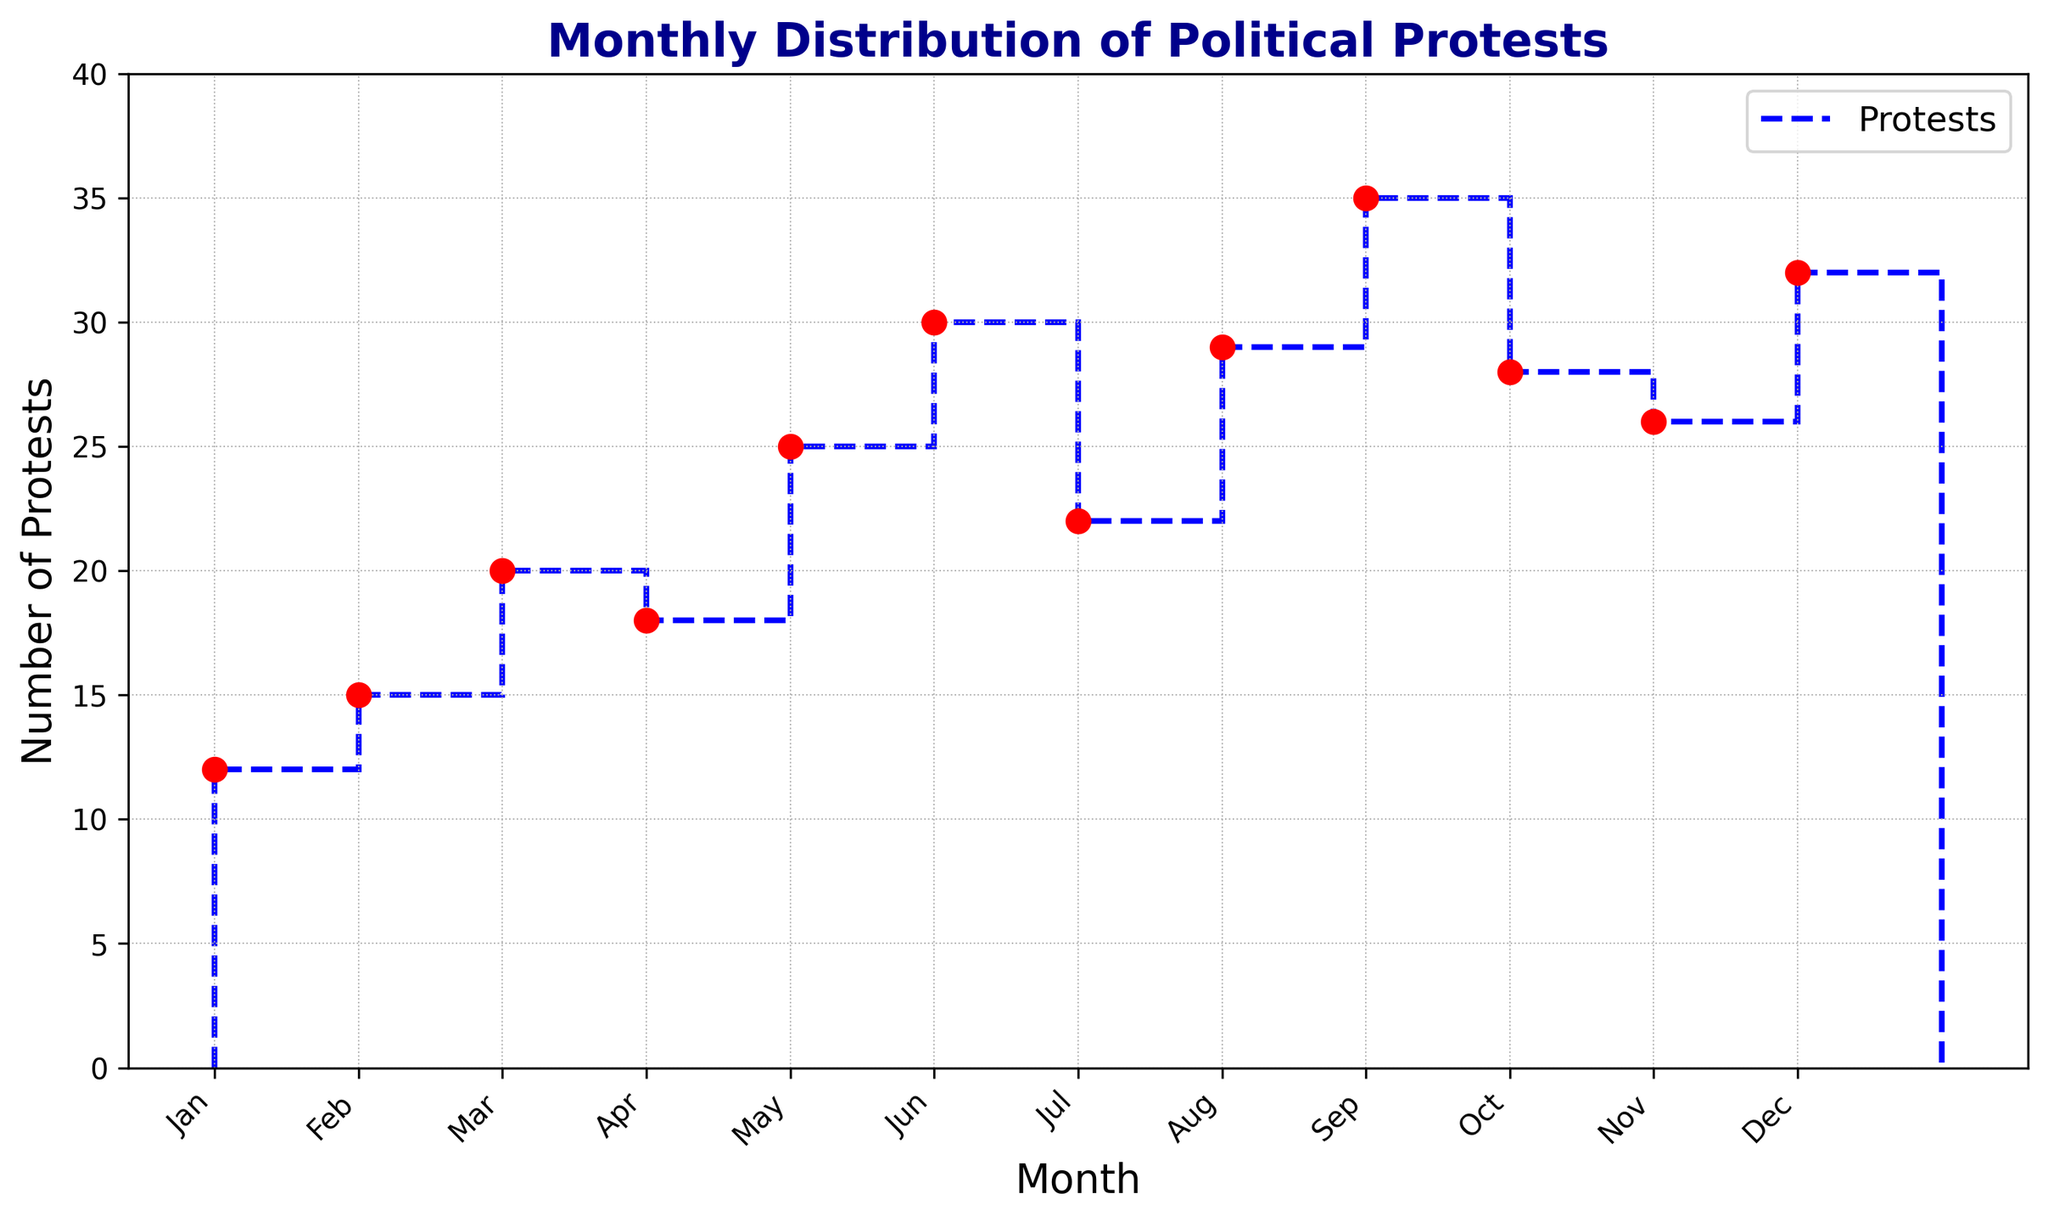What month had the highest number of political protests? Looking at the heights of the markers and stairs, we observe that September has the highest number, reaching up to 35 protests.
Answer: September Which two consecutive months had the greatest increase in the number of protests? To find the greatest increase, we observe the difference in the heights of the markers from one month to the next. The biggest jump is from June (30) to July (22), an increase of 8.
Answer: June to July How many total protests were reported from January to June? Adding up the number of protests reported each month from January to June we get: 12 + 15 + 20 + 18 + 25 + 30 = 120.
Answer: 120 What is the average number of political protests per month? Adding up all the protests for the year and dividing by the number of months: (12 + 15 + 20 + 18 + 25 + 30 + 22 + 29 + 35 + 28 + 26 + 32)/12 = 292/12 = 24.33.
Answer: 24.33 Is there any month where the number of protests decreased compared to the previous month? Checking the heights of the markers month by month, we find that in July (22) the number of protests decreased compared to June (30).
Answer: Yes, in July In which month(s) do we see almost equal numbers of protests? By comparing the heights visually, we see that August (29) and November (26) have relatively similar numbers of protests.
Answer: August and November What is the overall trend in the number of protests from January to December? From January to December, the general trend is upward with some fluctuations, but overall the protests tend to increase as the year progresses.
Answer: Upward Which month showed the second highest number of protests? Visually comparing all the heights, December had 32 protests, which is the second highest after September.
Answer: December What is the percentage increase in protests from January to December? The increase from January (12) to December (32) is (32-12)/12 * 100% = 20/12 * 100% = 166.67%.
Answer: 166.67% Is there a distinct seasonal pattern in the number of political protests? Observing the plot, there isn't a distinct seasonal pattern; the number of protests fluctuates throughout the year without clear seasonal peaks.
Answer: No 